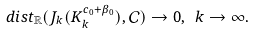<formula> <loc_0><loc_0><loc_500><loc_500>d i s t _ { \mathbb { R } } ( J _ { k } ( K ^ { c _ { 0 } + \beta _ { 0 } } _ { k } ) , \mathcal { C } ) \rightarrow 0 , \ k \rightarrow \infty .</formula> 